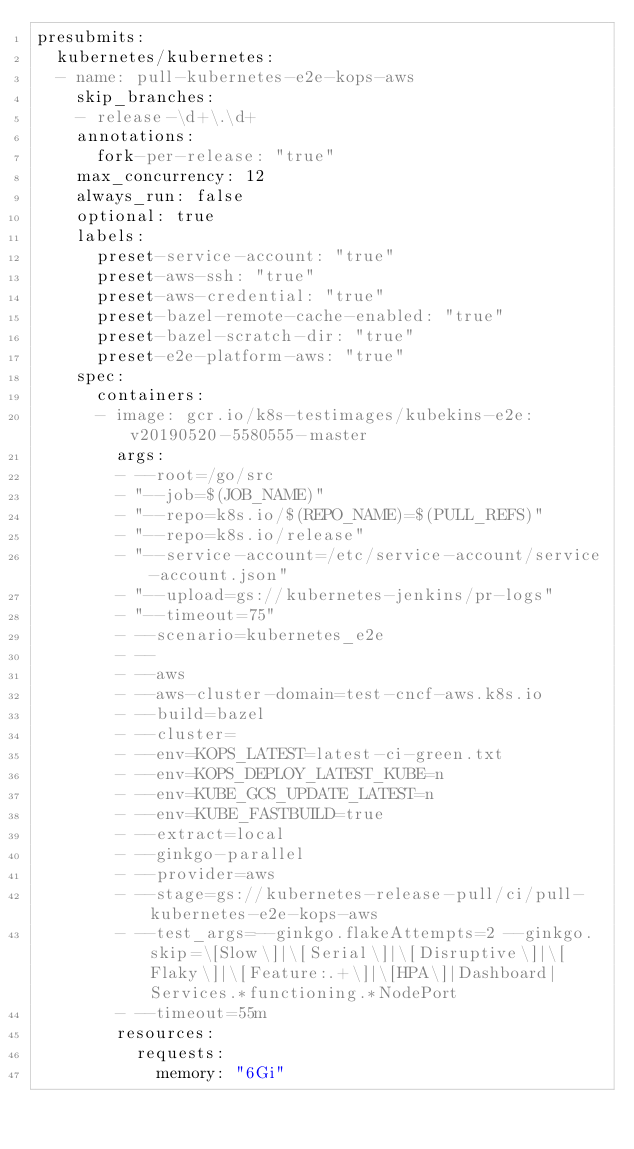<code> <loc_0><loc_0><loc_500><loc_500><_YAML_>presubmits:
  kubernetes/kubernetes:
  - name: pull-kubernetes-e2e-kops-aws
    skip_branches:
    - release-\d+\.\d+
    annotations:
      fork-per-release: "true"
    max_concurrency: 12
    always_run: false
    optional: true
    labels:
      preset-service-account: "true"
      preset-aws-ssh: "true"
      preset-aws-credential: "true"
      preset-bazel-remote-cache-enabled: "true"
      preset-bazel-scratch-dir: "true"
      preset-e2e-platform-aws: "true"
    spec:
      containers:
      - image: gcr.io/k8s-testimages/kubekins-e2e:v20190520-5580555-master
        args:
        - --root=/go/src
        - "--job=$(JOB_NAME)"
        - "--repo=k8s.io/$(REPO_NAME)=$(PULL_REFS)"
        - "--repo=k8s.io/release"
        - "--service-account=/etc/service-account/service-account.json"
        - "--upload=gs://kubernetes-jenkins/pr-logs"
        - "--timeout=75"
        - --scenario=kubernetes_e2e
        - --
        - --aws
        - --aws-cluster-domain=test-cncf-aws.k8s.io
        - --build=bazel
        - --cluster=
        - --env=KOPS_LATEST=latest-ci-green.txt
        - --env=KOPS_DEPLOY_LATEST_KUBE=n
        - --env=KUBE_GCS_UPDATE_LATEST=n
        - --env=KUBE_FASTBUILD=true
        - --extract=local
        - --ginkgo-parallel
        - --provider=aws
        - --stage=gs://kubernetes-release-pull/ci/pull-kubernetes-e2e-kops-aws
        - --test_args=--ginkgo.flakeAttempts=2 --ginkgo.skip=\[Slow\]|\[Serial\]|\[Disruptive\]|\[Flaky\]|\[Feature:.+\]|\[HPA\]|Dashboard|Services.*functioning.*NodePort
        - --timeout=55m
        resources:
          requests:
            memory: "6Gi"
</code> 